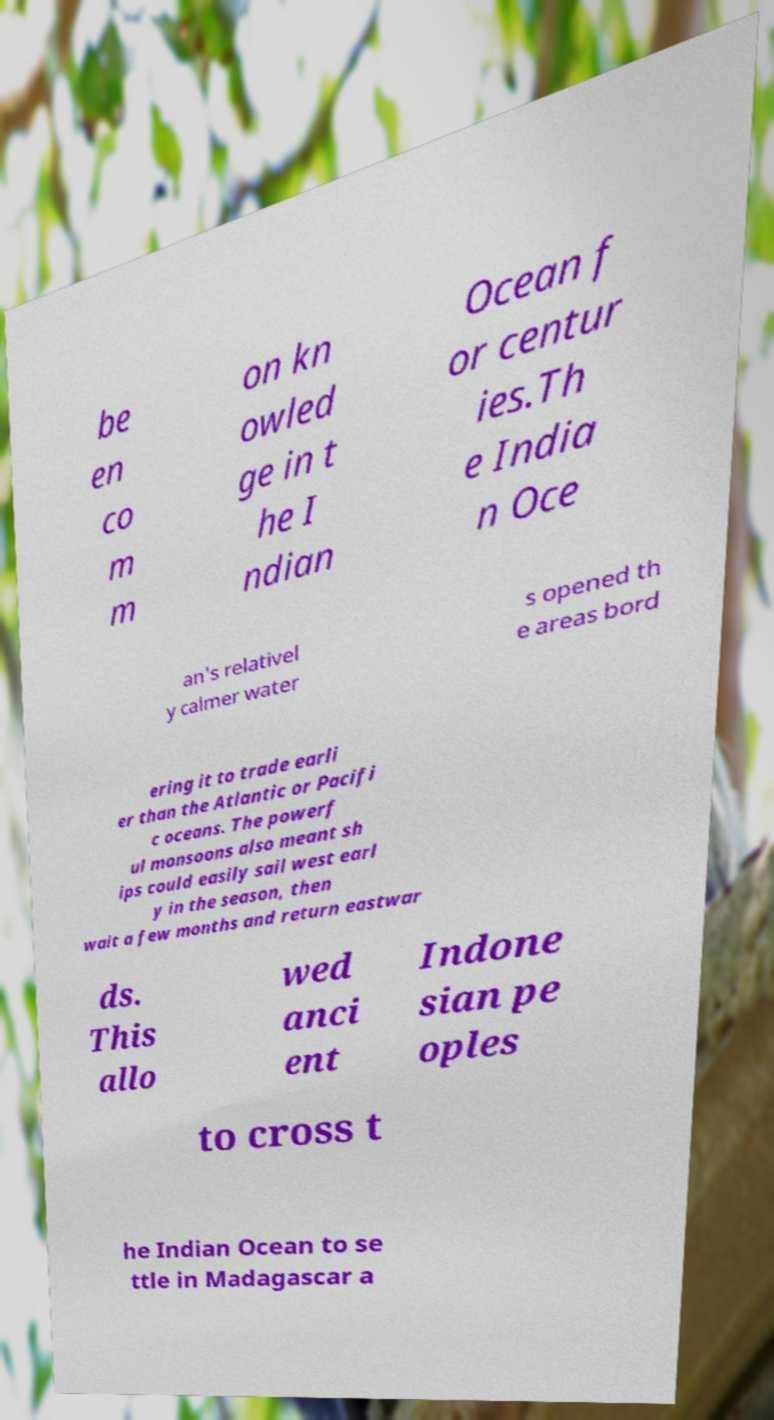Could you assist in decoding the text presented in this image and type it out clearly? be en co m m on kn owled ge in t he I ndian Ocean f or centur ies.Th e India n Oce an's relativel y calmer water s opened th e areas bord ering it to trade earli er than the Atlantic or Pacifi c oceans. The powerf ul monsoons also meant sh ips could easily sail west earl y in the season, then wait a few months and return eastwar ds. This allo wed anci ent Indone sian pe oples to cross t he Indian Ocean to se ttle in Madagascar a 